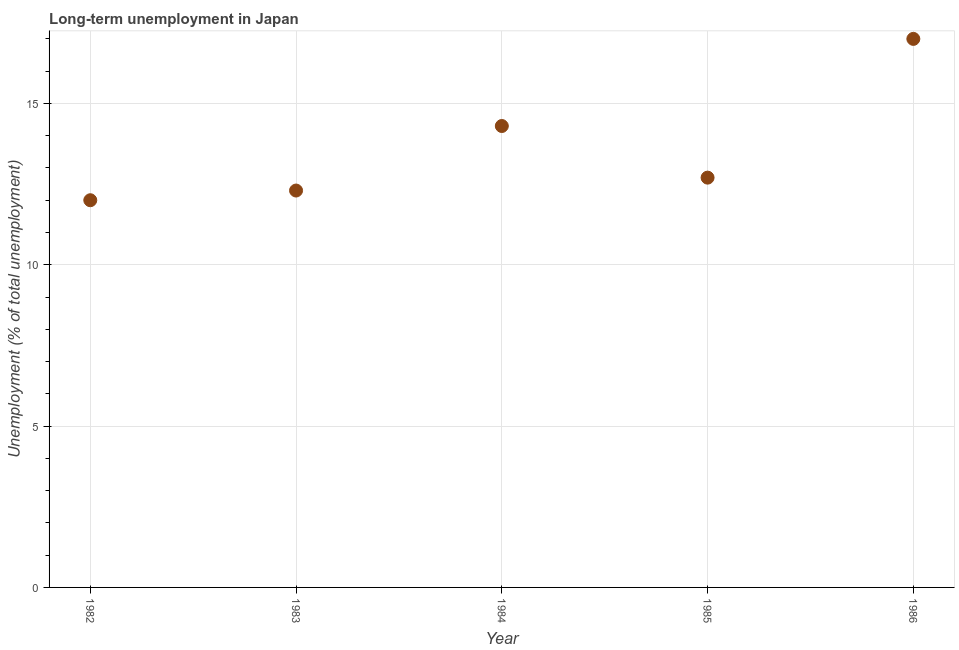What is the long-term unemployment in 1985?
Your answer should be compact. 12.7. Across all years, what is the maximum long-term unemployment?
Offer a very short reply. 17. What is the sum of the long-term unemployment?
Ensure brevity in your answer.  68.3. What is the difference between the long-term unemployment in 1982 and 1985?
Your response must be concise. -0.7. What is the average long-term unemployment per year?
Offer a terse response. 13.66. What is the median long-term unemployment?
Make the answer very short. 12.7. In how many years, is the long-term unemployment greater than 2 %?
Your response must be concise. 5. Do a majority of the years between 1986 and 1982 (inclusive) have long-term unemployment greater than 6 %?
Keep it short and to the point. Yes. What is the ratio of the long-term unemployment in 1982 to that in 1983?
Ensure brevity in your answer.  0.98. Is the long-term unemployment in 1983 less than that in 1985?
Keep it short and to the point. Yes. What is the difference between the highest and the second highest long-term unemployment?
Keep it short and to the point. 2.7. In how many years, is the long-term unemployment greater than the average long-term unemployment taken over all years?
Provide a short and direct response. 2. How many years are there in the graph?
Make the answer very short. 5. Are the values on the major ticks of Y-axis written in scientific E-notation?
Your response must be concise. No. Does the graph contain any zero values?
Your response must be concise. No. What is the title of the graph?
Offer a terse response. Long-term unemployment in Japan. What is the label or title of the Y-axis?
Your response must be concise. Unemployment (% of total unemployment). What is the Unemployment (% of total unemployment) in 1983?
Offer a very short reply. 12.3. What is the Unemployment (% of total unemployment) in 1984?
Ensure brevity in your answer.  14.3. What is the Unemployment (% of total unemployment) in 1985?
Provide a short and direct response. 12.7. What is the Unemployment (% of total unemployment) in 1986?
Keep it short and to the point. 17. What is the difference between the Unemployment (% of total unemployment) in 1982 and 1983?
Make the answer very short. -0.3. What is the difference between the Unemployment (% of total unemployment) in 1982 and 1985?
Offer a very short reply. -0.7. What is the difference between the Unemployment (% of total unemployment) in 1982 and 1986?
Provide a short and direct response. -5. What is the difference between the Unemployment (% of total unemployment) in 1983 and 1985?
Make the answer very short. -0.4. What is the difference between the Unemployment (% of total unemployment) in 1983 and 1986?
Your answer should be compact. -4.7. What is the difference between the Unemployment (% of total unemployment) in 1984 and 1985?
Your answer should be compact. 1.6. What is the difference between the Unemployment (% of total unemployment) in 1984 and 1986?
Your response must be concise. -2.7. What is the difference between the Unemployment (% of total unemployment) in 1985 and 1986?
Give a very brief answer. -4.3. What is the ratio of the Unemployment (% of total unemployment) in 1982 to that in 1983?
Your answer should be very brief. 0.98. What is the ratio of the Unemployment (% of total unemployment) in 1982 to that in 1984?
Provide a short and direct response. 0.84. What is the ratio of the Unemployment (% of total unemployment) in 1982 to that in 1985?
Ensure brevity in your answer.  0.94. What is the ratio of the Unemployment (% of total unemployment) in 1982 to that in 1986?
Ensure brevity in your answer.  0.71. What is the ratio of the Unemployment (% of total unemployment) in 1983 to that in 1984?
Offer a very short reply. 0.86. What is the ratio of the Unemployment (% of total unemployment) in 1983 to that in 1986?
Your response must be concise. 0.72. What is the ratio of the Unemployment (% of total unemployment) in 1984 to that in 1985?
Make the answer very short. 1.13. What is the ratio of the Unemployment (% of total unemployment) in 1984 to that in 1986?
Offer a very short reply. 0.84. What is the ratio of the Unemployment (% of total unemployment) in 1985 to that in 1986?
Offer a very short reply. 0.75. 